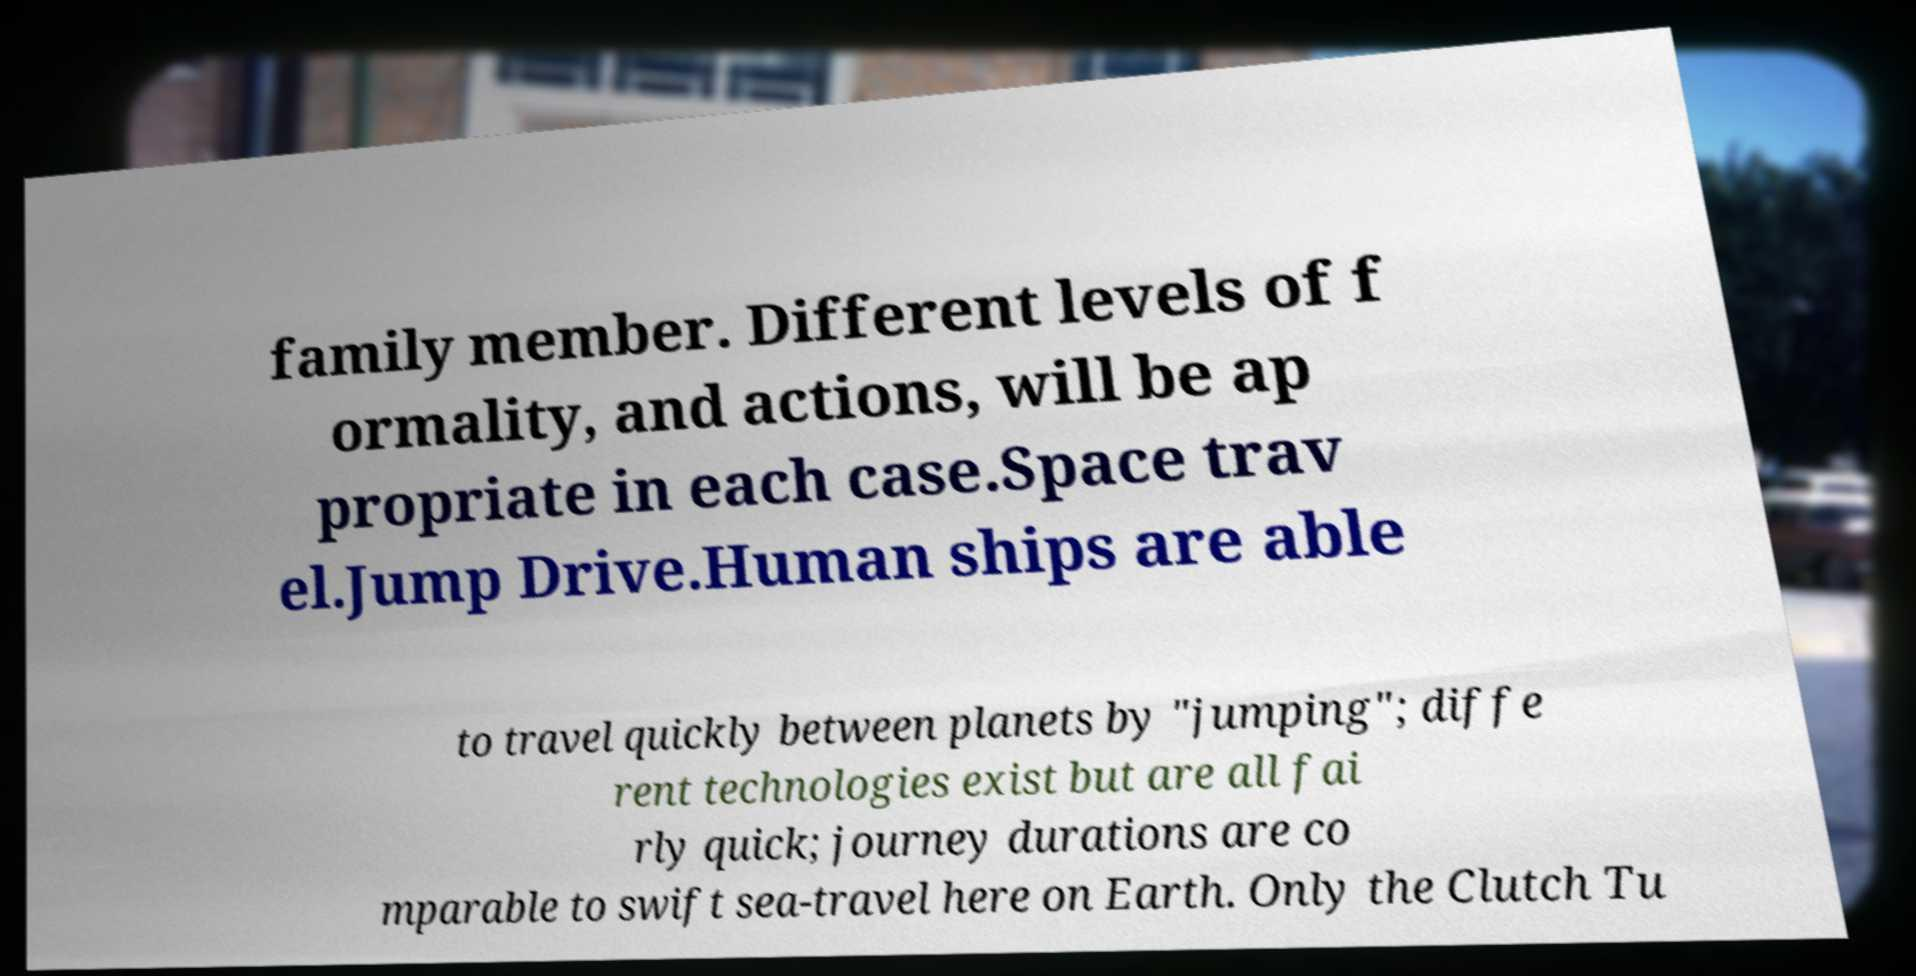I need the written content from this picture converted into text. Can you do that? family member. Different levels of f ormality, and actions, will be ap propriate in each case.Space trav el.Jump Drive.Human ships are able to travel quickly between planets by "jumping"; diffe rent technologies exist but are all fai rly quick; journey durations are co mparable to swift sea-travel here on Earth. Only the Clutch Tu 